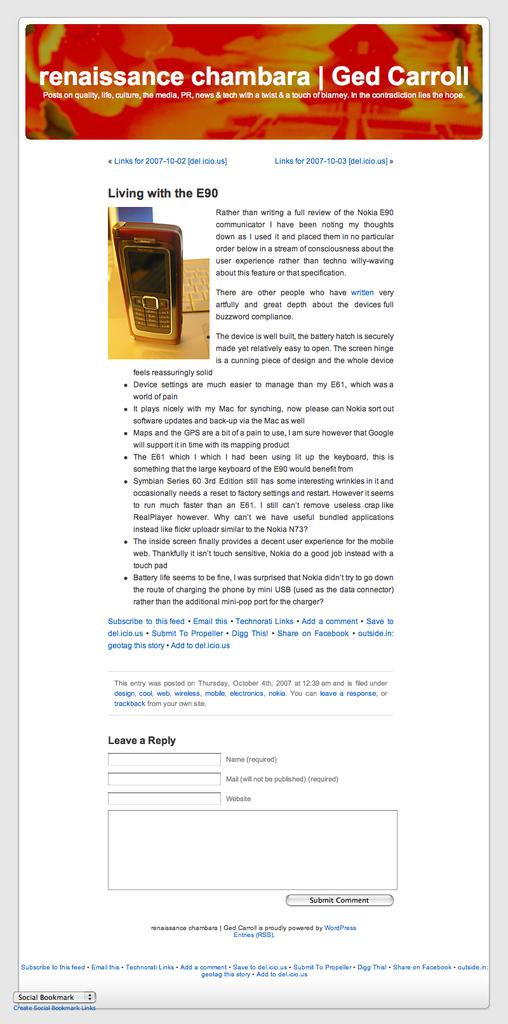What is displayed on the screen in the image? There is text visible on a screen in the image. What type of device is the screen part of? The screen is part of a mobile phone, which is visible in the image. Is the person in the image swimming in sleet? There is no person visible in the image, and swimming in sleet is not mentioned or depicted. 